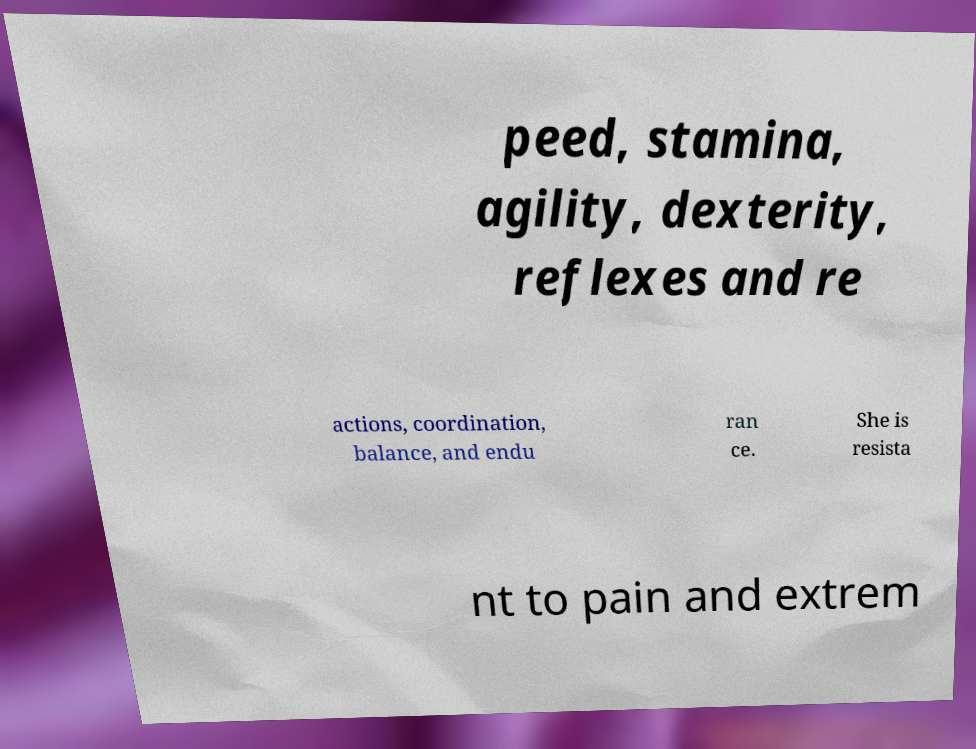There's text embedded in this image that I need extracted. Can you transcribe it verbatim? peed, stamina, agility, dexterity, reflexes and re actions, coordination, balance, and endu ran ce. She is resista nt to pain and extrem 